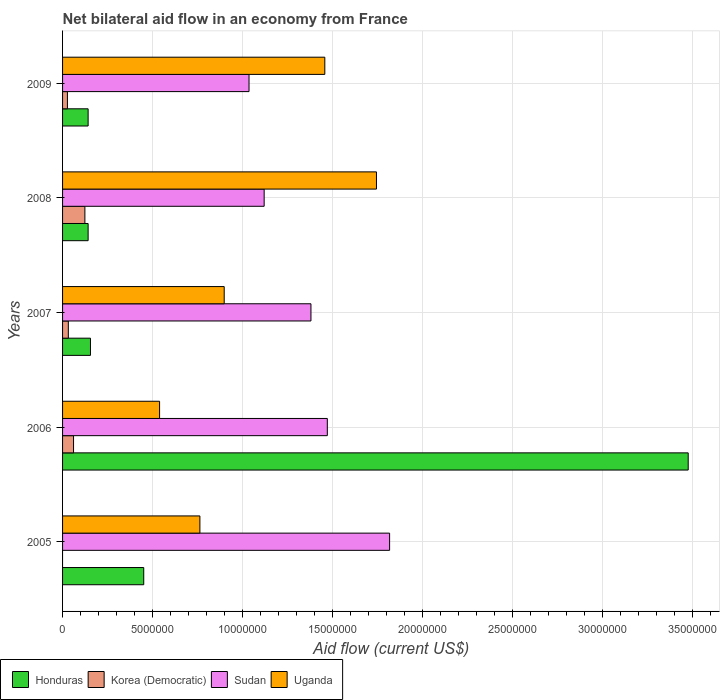Are the number of bars per tick equal to the number of legend labels?
Keep it short and to the point. No. How many bars are there on the 5th tick from the top?
Keep it short and to the point. 3. What is the net bilateral aid flow in Uganda in 2008?
Offer a terse response. 1.74e+07. Across all years, what is the maximum net bilateral aid flow in Sudan?
Your answer should be compact. 1.82e+07. Across all years, what is the minimum net bilateral aid flow in Sudan?
Your answer should be very brief. 1.04e+07. What is the total net bilateral aid flow in Sudan in the graph?
Your response must be concise. 6.82e+07. What is the difference between the net bilateral aid flow in Honduras in 2006 and that in 2008?
Provide a succinct answer. 3.33e+07. What is the difference between the net bilateral aid flow in Uganda in 2005 and the net bilateral aid flow in Korea (Democratic) in 2008?
Make the answer very short. 6.39e+06. What is the average net bilateral aid flow in Sudan per year?
Your response must be concise. 1.36e+07. In the year 2009, what is the difference between the net bilateral aid flow in Sudan and net bilateral aid flow in Korea (Democratic)?
Make the answer very short. 1.01e+07. What is the ratio of the net bilateral aid flow in Korea (Democratic) in 2007 to that in 2008?
Offer a very short reply. 0.26. What is the difference between the highest and the second highest net bilateral aid flow in Honduras?
Provide a succinct answer. 3.02e+07. What is the difference between the highest and the lowest net bilateral aid flow in Uganda?
Your answer should be compact. 1.20e+07. In how many years, is the net bilateral aid flow in Honduras greater than the average net bilateral aid flow in Honduras taken over all years?
Make the answer very short. 1. Is the sum of the net bilateral aid flow in Uganda in 2006 and 2007 greater than the maximum net bilateral aid flow in Sudan across all years?
Offer a very short reply. No. Is it the case that in every year, the sum of the net bilateral aid flow in Korea (Democratic) and net bilateral aid flow in Honduras is greater than the sum of net bilateral aid flow in Sudan and net bilateral aid flow in Uganda?
Offer a very short reply. Yes. What is the difference between two consecutive major ticks on the X-axis?
Offer a terse response. 5.00e+06. Does the graph contain grids?
Give a very brief answer. Yes. Where does the legend appear in the graph?
Your response must be concise. Bottom left. How many legend labels are there?
Your answer should be very brief. 4. How are the legend labels stacked?
Your answer should be very brief. Horizontal. What is the title of the graph?
Ensure brevity in your answer.  Net bilateral aid flow in an economy from France. Does "High income: OECD" appear as one of the legend labels in the graph?
Give a very brief answer. No. What is the label or title of the Y-axis?
Give a very brief answer. Years. What is the Aid flow (current US$) of Honduras in 2005?
Ensure brevity in your answer.  4.51e+06. What is the Aid flow (current US$) of Korea (Democratic) in 2005?
Provide a short and direct response. 0. What is the Aid flow (current US$) of Sudan in 2005?
Ensure brevity in your answer.  1.82e+07. What is the Aid flow (current US$) of Uganda in 2005?
Give a very brief answer. 7.63e+06. What is the Aid flow (current US$) in Honduras in 2006?
Provide a short and direct response. 3.48e+07. What is the Aid flow (current US$) in Sudan in 2006?
Offer a terse response. 1.47e+07. What is the Aid flow (current US$) in Uganda in 2006?
Provide a succinct answer. 5.39e+06. What is the Aid flow (current US$) in Honduras in 2007?
Offer a very short reply. 1.55e+06. What is the Aid flow (current US$) of Korea (Democratic) in 2007?
Offer a terse response. 3.20e+05. What is the Aid flow (current US$) in Sudan in 2007?
Your answer should be compact. 1.38e+07. What is the Aid flow (current US$) in Uganda in 2007?
Give a very brief answer. 8.98e+06. What is the Aid flow (current US$) in Honduras in 2008?
Offer a very short reply. 1.42e+06. What is the Aid flow (current US$) of Korea (Democratic) in 2008?
Give a very brief answer. 1.24e+06. What is the Aid flow (current US$) in Sudan in 2008?
Provide a short and direct response. 1.12e+07. What is the Aid flow (current US$) in Uganda in 2008?
Your answer should be compact. 1.74e+07. What is the Aid flow (current US$) of Honduras in 2009?
Provide a short and direct response. 1.42e+06. What is the Aid flow (current US$) of Sudan in 2009?
Your answer should be compact. 1.04e+07. What is the Aid flow (current US$) in Uganda in 2009?
Provide a short and direct response. 1.46e+07. Across all years, what is the maximum Aid flow (current US$) of Honduras?
Offer a terse response. 3.48e+07. Across all years, what is the maximum Aid flow (current US$) of Korea (Democratic)?
Your answer should be very brief. 1.24e+06. Across all years, what is the maximum Aid flow (current US$) in Sudan?
Provide a short and direct response. 1.82e+07. Across all years, what is the maximum Aid flow (current US$) in Uganda?
Offer a very short reply. 1.74e+07. Across all years, what is the minimum Aid flow (current US$) in Honduras?
Provide a short and direct response. 1.42e+06. Across all years, what is the minimum Aid flow (current US$) of Sudan?
Offer a terse response. 1.04e+07. Across all years, what is the minimum Aid flow (current US$) of Uganda?
Provide a short and direct response. 5.39e+06. What is the total Aid flow (current US$) in Honduras in the graph?
Make the answer very short. 4.37e+07. What is the total Aid flow (current US$) in Korea (Democratic) in the graph?
Keep it short and to the point. 2.44e+06. What is the total Aid flow (current US$) of Sudan in the graph?
Keep it short and to the point. 6.82e+07. What is the total Aid flow (current US$) of Uganda in the graph?
Offer a terse response. 5.40e+07. What is the difference between the Aid flow (current US$) of Honduras in 2005 and that in 2006?
Give a very brief answer. -3.02e+07. What is the difference between the Aid flow (current US$) in Sudan in 2005 and that in 2006?
Provide a short and direct response. 3.46e+06. What is the difference between the Aid flow (current US$) of Uganda in 2005 and that in 2006?
Make the answer very short. 2.24e+06. What is the difference between the Aid flow (current US$) of Honduras in 2005 and that in 2007?
Your answer should be very brief. 2.96e+06. What is the difference between the Aid flow (current US$) of Sudan in 2005 and that in 2007?
Ensure brevity in your answer.  4.37e+06. What is the difference between the Aid flow (current US$) in Uganda in 2005 and that in 2007?
Make the answer very short. -1.35e+06. What is the difference between the Aid flow (current US$) in Honduras in 2005 and that in 2008?
Provide a succinct answer. 3.09e+06. What is the difference between the Aid flow (current US$) of Sudan in 2005 and that in 2008?
Offer a very short reply. 6.97e+06. What is the difference between the Aid flow (current US$) in Uganda in 2005 and that in 2008?
Ensure brevity in your answer.  -9.81e+06. What is the difference between the Aid flow (current US$) of Honduras in 2005 and that in 2009?
Make the answer very short. 3.09e+06. What is the difference between the Aid flow (current US$) in Sudan in 2005 and that in 2009?
Offer a terse response. 7.81e+06. What is the difference between the Aid flow (current US$) of Uganda in 2005 and that in 2009?
Offer a very short reply. -6.94e+06. What is the difference between the Aid flow (current US$) of Honduras in 2006 and that in 2007?
Keep it short and to the point. 3.32e+07. What is the difference between the Aid flow (current US$) of Korea (Democratic) in 2006 and that in 2007?
Give a very brief answer. 2.90e+05. What is the difference between the Aid flow (current US$) of Sudan in 2006 and that in 2007?
Keep it short and to the point. 9.10e+05. What is the difference between the Aid flow (current US$) of Uganda in 2006 and that in 2007?
Give a very brief answer. -3.59e+06. What is the difference between the Aid flow (current US$) in Honduras in 2006 and that in 2008?
Make the answer very short. 3.33e+07. What is the difference between the Aid flow (current US$) of Korea (Democratic) in 2006 and that in 2008?
Ensure brevity in your answer.  -6.30e+05. What is the difference between the Aid flow (current US$) of Sudan in 2006 and that in 2008?
Keep it short and to the point. 3.51e+06. What is the difference between the Aid flow (current US$) in Uganda in 2006 and that in 2008?
Offer a terse response. -1.20e+07. What is the difference between the Aid flow (current US$) in Honduras in 2006 and that in 2009?
Ensure brevity in your answer.  3.33e+07. What is the difference between the Aid flow (current US$) of Sudan in 2006 and that in 2009?
Give a very brief answer. 4.35e+06. What is the difference between the Aid flow (current US$) of Uganda in 2006 and that in 2009?
Keep it short and to the point. -9.18e+06. What is the difference between the Aid flow (current US$) of Korea (Democratic) in 2007 and that in 2008?
Keep it short and to the point. -9.20e+05. What is the difference between the Aid flow (current US$) of Sudan in 2007 and that in 2008?
Provide a succinct answer. 2.60e+06. What is the difference between the Aid flow (current US$) of Uganda in 2007 and that in 2008?
Provide a short and direct response. -8.46e+06. What is the difference between the Aid flow (current US$) in Sudan in 2007 and that in 2009?
Keep it short and to the point. 3.44e+06. What is the difference between the Aid flow (current US$) in Uganda in 2007 and that in 2009?
Keep it short and to the point. -5.59e+06. What is the difference between the Aid flow (current US$) in Honduras in 2008 and that in 2009?
Make the answer very short. 0. What is the difference between the Aid flow (current US$) of Korea (Democratic) in 2008 and that in 2009?
Offer a very short reply. 9.70e+05. What is the difference between the Aid flow (current US$) of Sudan in 2008 and that in 2009?
Give a very brief answer. 8.40e+05. What is the difference between the Aid flow (current US$) in Uganda in 2008 and that in 2009?
Offer a terse response. 2.87e+06. What is the difference between the Aid flow (current US$) in Honduras in 2005 and the Aid flow (current US$) in Korea (Democratic) in 2006?
Your answer should be compact. 3.90e+06. What is the difference between the Aid flow (current US$) of Honduras in 2005 and the Aid flow (current US$) of Sudan in 2006?
Offer a very short reply. -1.02e+07. What is the difference between the Aid flow (current US$) in Honduras in 2005 and the Aid flow (current US$) in Uganda in 2006?
Ensure brevity in your answer.  -8.80e+05. What is the difference between the Aid flow (current US$) in Sudan in 2005 and the Aid flow (current US$) in Uganda in 2006?
Ensure brevity in your answer.  1.28e+07. What is the difference between the Aid flow (current US$) in Honduras in 2005 and the Aid flow (current US$) in Korea (Democratic) in 2007?
Provide a short and direct response. 4.19e+06. What is the difference between the Aid flow (current US$) in Honduras in 2005 and the Aid flow (current US$) in Sudan in 2007?
Make the answer very short. -9.29e+06. What is the difference between the Aid flow (current US$) of Honduras in 2005 and the Aid flow (current US$) of Uganda in 2007?
Your answer should be compact. -4.47e+06. What is the difference between the Aid flow (current US$) in Sudan in 2005 and the Aid flow (current US$) in Uganda in 2007?
Offer a terse response. 9.19e+06. What is the difference between the Aid flow (current US$) in Honduras in 2005 and the Aid flow (current US$) in Korea (Democratic) in 2008?
Give a very brief answer. 3.27e+06. What is the difference between the Aid flow (current US$) of Honduras in 2005 and the Aid flow (current US$) of Sudan in 2008?
Keep it short and to the point. -6.69e+06. What is the difference between the Aid flow (current US$) in Honduras in 2005 and the Aid flow (current US$) in Uganda in 2008?
Your answer should be compact. -1.29e+07. What is the difference between the Aid flow (current US$) of Sudan in 2005 and the Aid flow (current US$) of Uganda in 2008?
Provide a succinct answer. 7.30e+05. What is the difference between the Aid flow (current US$) of Honduras in 2005 and the Aid flow (current US$) of Korea (Democratic) in 2009?
Keep it short and to the point. 4.24e+06. What is the difference between the Aid flow (current US$) of Honduras in 2005 and the Aid flow (current US$) of Sudan in 2009?
Give a very brief answer. -5.85e+06. What is the difference between the Aid flow (current US$) of Honduras in 2005 and the Aid flow (current US$) of Uganda in 2009?
Give a very brief answer. -1.01e+07. What is the difference between the Aid flow (current US$) of Sudan in 2005 and the Aid flow (current US$) of Uganda in 2009?
Make the answer very short. 3.60e+06. What is the difference between the Aid flow (current US$) in Honduras in 2006 and the Aid flow (current US$) in Korea (Democratic) in 2007?
Offer a very short reply. 3.44e+07. What is the difference between the Aid flow (current US$) in Honduras in 2006 and the Aid flow (current US$) in Sudan in 2007?
Offer a terse response. 2.10e+07. What is the difference between the Aid flow (current US$) of Honduras in 2006 and the Aid flow (current US$) of Uganda in 2007?
Give a very brief answer. 2.58e+07. What is the difference between the Aid flow (current US$) of Korea (Democratic) in 2006 and the Aid flow (current US$) of Sudan in 2007?
Offer a very short reply. -1.32e+07. What is the difference between the Aid flow (current US$) of Korea (Democratic) in 2006 and the Aid flow (current US$) of Uganda in 2007?
Your answer should be very brief. -8.37e+06. What is the difference between the Aid flow (current US$) in Sudan in 2006 and the Aid flow (current US$) in Uganda in 2007?
Make the answer very short. 5.73e+06. What is the difference between the Aid flow (current US$) of Honduras in 2006 and the Aid flow (current US$) of Korea (Democratic) in 2008?
Offer a very short reply. 3.35e+07. What is the difference between the Aid flow (current US$) in Honduras in 2006 and the Aid flow (current US$) in Sudan in 2008?
Keep it short and to the point. 2.36e+07. What is the difference between the Aid flow (current US$) in Honduras in 2006 and the Aid flow (current US$) in Uganda in 2008?
Give a very brief answer. 1.73e+07. What is the difference between the Aid flow (current US$) in Korea (Democratic) in 2006 and the Aid flow (current US$) in Sudan in 2008?
Keep it short and to the point. -1.06e+07. What is the difference between the Aid flow (current US$) of Korea (Democratic) in 2006 and the Aid flow (current US$) of Uganda in 2008?
Your answer should be compact. -1.68e+07. What is the difference between the Aid flow (current US$) in Sudan in 2006 and the Aid flow (current US$) in Uganda in 2008?
Provide a succinct answer. -2.73e+06. What is the difference between the Aid flow (current US$) in Honduras in 2006 and the Aid flow (current US$) in Korea (Democratic) in 2009?
Ensure brevity in your answer.  3.45e+07. What is the difference between the Aid flow (current US$) in Honduras in 2006 and the Aid flow (current US$) in Sudan in 2009?
Give a very brief answer. 2.44e+07. What is the difference between the Aid flow (current US$) in Honduras in 2006 and the Aid flow (current US$) in Uganda in 2009?
Make the answer very short. 2.02e+07. What is the difference between the Aid flow (current US$) of Korea (Democratic) in 2006 and the Aid flow (current US$) of Sudan in 2009?
Make the answer very short. -9.75e+06. What is the difference between the Aid flow (current US$) in Korea (Democratic) in 2006 and the Aid flow (current US$) in Uganda in 2009?
Offer a terse response. -1.40e+07. What is the difference between the Aid flow (current US$) of Sudan in 2006 and the Aid flow (current US$) of Uganda in 2009?
Provide a short and direct response. 1.40e+05. What is the difference between the Aid flow (current US$) in Honduras in 2007 and the Aid flow (current US$) in Sudan in 2008?
Offer a terse response. -9.65e+06. What is the difference between the Aid flow (current US$) of Honduras in 2007 and the Aid flow (current US$) of Uganda in 2008?
Ensure brevity in your answer.  -1.59e+07. What is the difference between the Aid flow (current US$) of Korea (Democratic) in 2007 and the Aid flow (current US$) of Sudan in 2008?
Make the answer very short. -1.09e+07. What is the difference between the Aid flow (current US$) of Korea (Democratic) in 2007 and the Aid flow (current US$) of Uganda in 2008?
Your answer should be very brief. -1.71e+07. What is the difference between the Aid flow (current US$) of Sudan in 2007 and the Aid flow (current US$) of Uganda in 2008?
Offer a very short reply. -3.64e+06. What is the difference between the Aid flow (current US$) in Honduras in 2007 and the Aid flow (current US$) in Korea (Democratic) in 2009?
Keep it short and to the point. 1.28e+06. What is the difference between the Aid flow (current US$) in Honduras in 2007 and the Aid flow (current US$) in Sudan in 2009?
Your answer should be compact. -8.81e+06. What is the difference between the Aid flow (current US$) in Honduras in 2007 and the Aid flow (current US$) in Uganda in 2009?
Ensure brevity in your answer.  -1.30e+07. What is the difference between the Aid flow (current US$) in Korea (Democratic) in 2007 and the Aid flow (current US$) in Sudan in 2009?
Offer a terse response. -1.00e+07. What is the difference between the Aid flow (current US$) in Korea (Democratic) in 2007 and the Aid flow (current US$) in Uganda in 2009?
Your answer should be very brief. -1.42e+07. What is the difference between the Aid flow (current US$) in Sudan in 2007 and the Aid flow (current US$) in Uganda in 2009?
Make the answer very short. -7.70e+05. What is the difference between the Aid flow (current US$) in Honduras in 2008 and the Aid flow (current US$) in Korea (Democratic) in 2009?
Make the answer very short. 1.15e+06. What is the difference between the Aid flow (current US$) of Honduras in 2008 and the Aid flow (current US$) of Sudan in 2009?
Provide a short and direct response. -8.94e+06. What is the difference between the Aid flow (current US$) of Honduras in 2008 and the Aid flow (current US$) of Uganda in 2009?
Give a very brief answer. -1.32e+07. What is the difference between the Aid flow (current US$) in Korea (Democratic) in 2008 and the Aid flow (current US$) in Sudan in 2009?
Offer a very short reply. -9.12e+06. What is the difference between the Aid flow (current US$) of Korea (Democratic) in 2008 and the Aid flow (current US$) of Uganda in 2009?
Keep it short and to the point. -1.33e+07. What is the difference between the Aid flow (current US$) of Sudan in 2008 and the Aid flow (current US$) of Uganda in 2009?
Your answer should be very brief. -3.37e+06. What is the average Aid flow (current US$) in Honduras per year?
Keep it short and to the point. 8.73e+06. What is the average Aid flow (current US$) of Korea (Democratic) per year?
Ensure brevity in your answer.  4.88e+05. What is the average Aid flow (current US$) of Sudan per year?
Your response must be concise. 1.36e+07. What is the average Aid flow (current US$) in Uganda per year?
Your response must be concise. 1.08e+07. In the year 2005, what is the difference between the Aid flow (current US$) in Honduras and Aid flow (current US$) in Sudan?
Your answer should be compact. -1.37e+07. In the year 2005, what is the difference between the Aid flow (current US$) in Honduras and Aid flow (current US$) in Uganda?
Provide a succinct answer. -3.12e+06. In the year 2005, what is the difference between the Aid flow (current US$) in Sudan and Aid flow (current US$) in Uganda?
Provide a short and direct response. 1.05e+07. In the year 2006, what is the difference between the Aid flow (current US$) of Honduras and Aid flow (current US$) of Korea (Democratic)?
Your answer should be compact. 3.42e+07. In the year 2006, what is the difference between the Aid flow (current US$) in Honduras and Aid flow (current US$) in Sudan?
Offer a very short reply. 2.00e+07. In the year 2006, what is the difference between the Aid flow (current US$) of Honduras and Aid flow (current US$) of Uganda?
Provide a succinct answer. 2.94e+07. In the year 2006, what is the difference between the Aid flow (current US$) in Korea (Democratic) and Aid flow (current US$) in Sudan?
Your answer should be compact. -1.41e+07. In the year 2006, what is the difference between the Aid flow (current US$) of Korea (Democratic) and Aid flow (current US$) of Uganda?
Give a very brief answer. -4.78e+06. In the year 2006, what is the difference between the Aid flow (current US$) in Sudan and Aid flow (current US$) in Uganda?
Ensure brevity in your answer.  9.32e+06. In the year 2007, what is the difference between the Aid flow (current US$) in Honduras and Aid flow (current US$) in Korea (Democratic)?
Give a very brief answer. 1.23e+06. In the year 2007, what is the difference between the Aid flow (current US$) of Honduras and Aid flow (current US$) of Sudan?
Keep it short and to the point. -1.22e+07. In the year 2007, what is the difference between the Aid flow (current US$) of Honduras and Aid flow (current US$) of Uganda?
Your answer should be compact. -7.43e+06. In the year 2007, what is the difference between the Aid flow (current US$) of Korea (Democratic) and Aid flow (current US$) of Sudan?
Ensure brevity in your answer.  -1.35e+07. In the year 2007, what is the difference between the Aid flow (current US$) of Korea (Democratic) and Aid flow (current US$) of Uganda?
Your answer should be very brief. -8.66e+06. In the year 2007, what is the difference between the Aid flow (current US$) in Sudan and Aid flow (current US$) in Uganda?
Make the answer very short. 4.82e+06. In the year 2008, what is the difference between the Aid flow (current US$) of Honduras and Aid flow (current US$) of Sudan?
Your answer should be compact. -9.78e+06. In the year 2008, what is the difference between the Aid flow (current US$) in Honduras and Aid flow (current US$) in Uganda?
Give a very brief answer. -1.60e+07. In the year 2008, what is the difference between the Aid flow (current US$) in Korea (Democratic) and Aid flow (current US$) in Sudan?
Your answer should be very brief. -9.96e+06. In the year 2008, what is the difference between the Aid flow (current US$) in Korea (Democratic) and Aid flow (current US$) in Uganda?
Make the answer very short. -1.62e+07. In the year 2008, what is the difference between the Aid flow (current US$) of Sudan and Aid flow (current US$) of Uganda?
Provide a succinct answer. -6.24e+06. In the year 2009, what is the difference between the Aid flow (current US$) in Honduras and Aid flow (current US$) in Korea (Democratic)?
Give a very brief answer. 1.15e+06. In the year 2009, what is the difference between the Aid flow (current US$) of Honduras and Aid flow (current US$) of Sudan?
Your response must be concise. -8.94e+06. In the year 2009, what is the difference between the Aid flow (current US$) in Honduras and Aid flow (current US$) in Uganda?
Offer a very short reply. -1.32e+07. In the year 2009, what is the difference between the Aid flow (current US$) in Korea (Democratic) and Aid flow (current US$) in Sudan?
Your answer should be very brief. -1.01e+07. In the year 2009, what is the difference between the Aid flow (current US$) of Korea (Democratic) and Aid flow (current US$) of Uganda?
Offer a terse response. -1.43e+07. In the year 2009, what is the difference between the Aid flow (current US$) of Sudan and Aid flow (current US$) of Uganda?
Your answer should be very brief. -4.21e+06. What is the ratio of the Aid flow (current US$) in Honduras in 2005 to that in 2006?
Offer a very short reply. 0.13. What is the ratio of the Aid flow (current US$) in Sudan in 2005 to that in 2006?
Keep it short and to the point. 1.24. What is the ratio of the Aid flow (current US$) of Uganda in 2005 to that in 2006?
Provide a succinct answer. 1.42. What is the ratio of the Aid flow (current US$) of Honduras in 2005 to that in 2007?
Keep it short and to the point. 2.91. What is the ratio of the Aid flow (current US$) of Sudan in 2005 to that in 2007?
Give a very brief answer. 1.32. What is the ratio of the Aid flow (current US$) of Uganda in 2005 to that in 2007?
Offer a terse response. 0.85. What is the ratio of the Aid flow (current US$) in Honduras in 2005 to that in 2008?
Your response must be concise. 3.18. What is the ratio of the Aid flow (current US$) in Sudan in 2005 to that in 2008?
Your answer should be very brief. 1.62. What is the ratio of the Aid flow (current US$) of Uganda in 2005 to that in 2008?
Ensure brevity in your answer.  0.44. What is the ratio of the Aid flow (current US$) in Honduras in 2005 to that in 2009?
Your answer should be very brief. 3.18. What is the ratio of the Aid flow (current US$) in Sudan in 2005 to that in 2009?
Provide a succinct answer. 1.75. What is the ratio of the Aid flow (current US$) of Uganda in 2005 to that in 2009?
Your response must be concise. 0.52. What is the ratio of the Aid flow (current US$) in Honduras in 2006 to that in 2007?
Keep it short and to the point. 22.43. What is the ratio of the Aid flow (current US$) in Korea (Democratic) in 2006 to that in 2007?
Give a very brief answer. 1.91. What is the ratio of the Aid flow (current US$) in Sudan in 2006 to that in 2007?
Your answer should be compact. 1.07. What is the ratio of the Aid flow (current US$) in Uganda in 2006 to that in 2007?
Your response must be concise. 0.6. What is the ratio of the Aid flow (current US$) of Honduras in 2006 to that in 2008?
Offer a very short reply. 24.48. What is the ratio of the Aid flow (current US$) of Korea (Democratic) in 2006 to that in 2008?
Provide a succinct answer. 0.49. What is the ratio of the Aid flow (current US$) of Sudan in 2006 to that in 2008?
Keep it short and to the point. 1.31. What is the ratio of the Aid flow (current US$) of Uganda in 2006 to that in 2008?
Ensure brevity in your answer.  0.31. What is the ratio of the Aid flow (current US$) of Honduras in 2006 to that in 2009?
Offer a terse response. 24.48. What is the ratio of the Aid flow (current US$) in Korea (Democratic) in 2006 to that in 2009?
Your answer should be very brief. 2.26. What is the ratio of the Aid flow (current US$) of Sudan in 2006 to that in 2009?
Keep it short and to the point. 1.42. What is the ratio of the Aid flow (current US$) in Uganda in 2006 to that in 2009?
Your answer should be compact. 0.37. What is the ratio of the Aid flow (current US$) in Honduras in 2007 to that in 2008?
Keep it short and to the point. 1.09. What is the ratio of the Aid flow (current US$) of Korea (Democratic) in 2007 to that in 2008?
Provide a short and direct response. 0.26. What is the ratio of the Aid flow (current US$) of Sudan in 2007 to that in 2008?
Give a very brief answer. 1.23. What is the ratio of the Aid flow (current US$) in Uganda in 2007 to that in 2008?
Make the answer very short. 0.51. What is the ratio of the Aid flow (current US$) in Honduras in 2007 to that in 2009?
Give a very brief answer. 1.09. What is the ratio of the Aid flow (current US$) in Korea (Democratic) in 2007 to that in 2009?
Make the answer very short. 1.19. What is the ratio of the Aid flow (current US$) in Sudan in 2007 to that in 2009?
Your answer should be very brief. 1.33. What is the ratio of the Aid flow (current US$) of Uganda in 2007 to that in 2009?
Keep it short and to the point. 0.62. What is the ratio of the Aid flow (current US$) in Honduras in 2008 to that in 2009?
Offer a terse response. 1. What is the ratio of the Aid flow (current US$) of Korea (Democratic) in 2008 to that in 2009?
Offer a terse response. 4.59. What is the ratio of the Aid flow (current US$) of Sudan in 2008 to that in 2009?
Provide a short and direct response. 1.08. What is the ratio of the Aid flow (current US$) in Uganda in 2008 to that in 2009?
Offer a terse response. 1.2. What is the difference between the highest and the second highest Aid flow (current US$) in Honduras?
Provide a short and direct response. 3.02e+07. What is the difference between the highest and the second highest Aid flow (current US$) of Korea (Democratic)?
Ensure brevity in your answer.  6.30e+05. What is the difference between the highest and the second highest Aid flow (current US$) in Sudan?
Keep it short and to the point. 3.46e+06. What is the difference between the highest and the second highest Aid flow (current US$) in Uganda?
Make the answer very short. 2.87e+06. What is the difference between the highest and the lowest Aid flow (current US$) in Honduras?
Provide a succinct answer. 3.33e+07. What is the difference between the highest and the lowest Aid flow (current US$) in Korea (Democratic)?
Keep it short and to the point. 1.24e+06. What is the difference between the highest and the lowest Aid flow (current US$) of Sudan?
Your answer should be very brief. 7.81e+06. What is the difference between the highest and the lowest Aid flow (current US$) of Uganda?
Your response must be concise. 1.20e+07. 